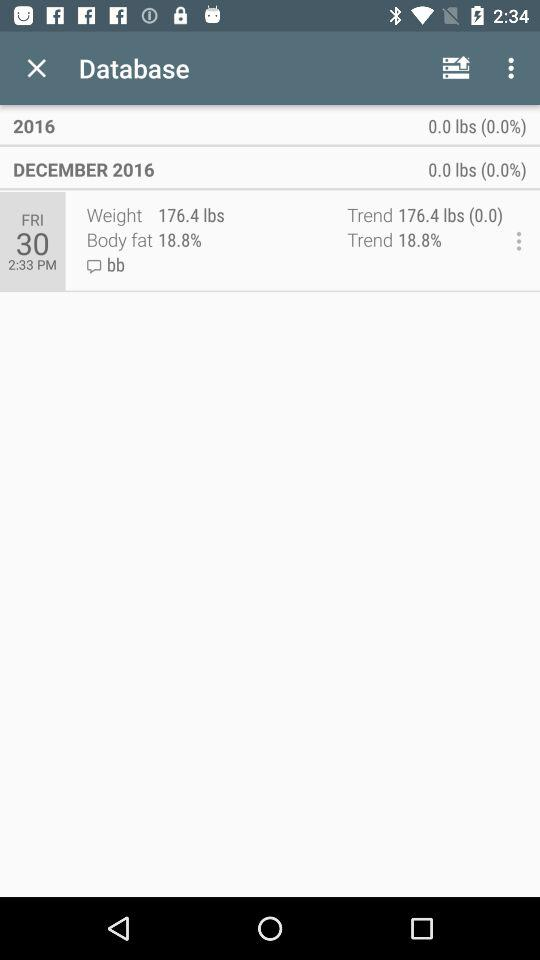What's the weight? The weight is 176.4 lbs. 